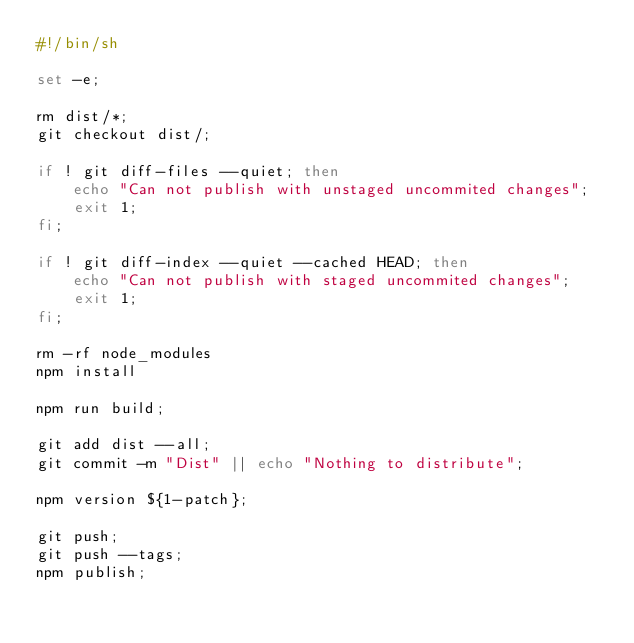<code> <loc_0><loc_0><loc_500><loc_500><_Bash_>#!/bin/sh

set -e;

rm dist/*;
git checkout dist/;

if ! git diff-files --quiet; then
    echo "Can not publish with unstaged uncommited changes";
    exit 1;
fi;

if ! git diff-index --quiet --cached HEAD; then
    echo "Can not publish with staged uncommited changes";
    exit 1;
fi;

rm -rf node_modules
npm install

npm run build;

git add dist --all;
git commit -m "Dist" || echo "Nothing to distribute";

npm version ${1-patch};

git push;
git push --tags;
npm publish;
</code> 